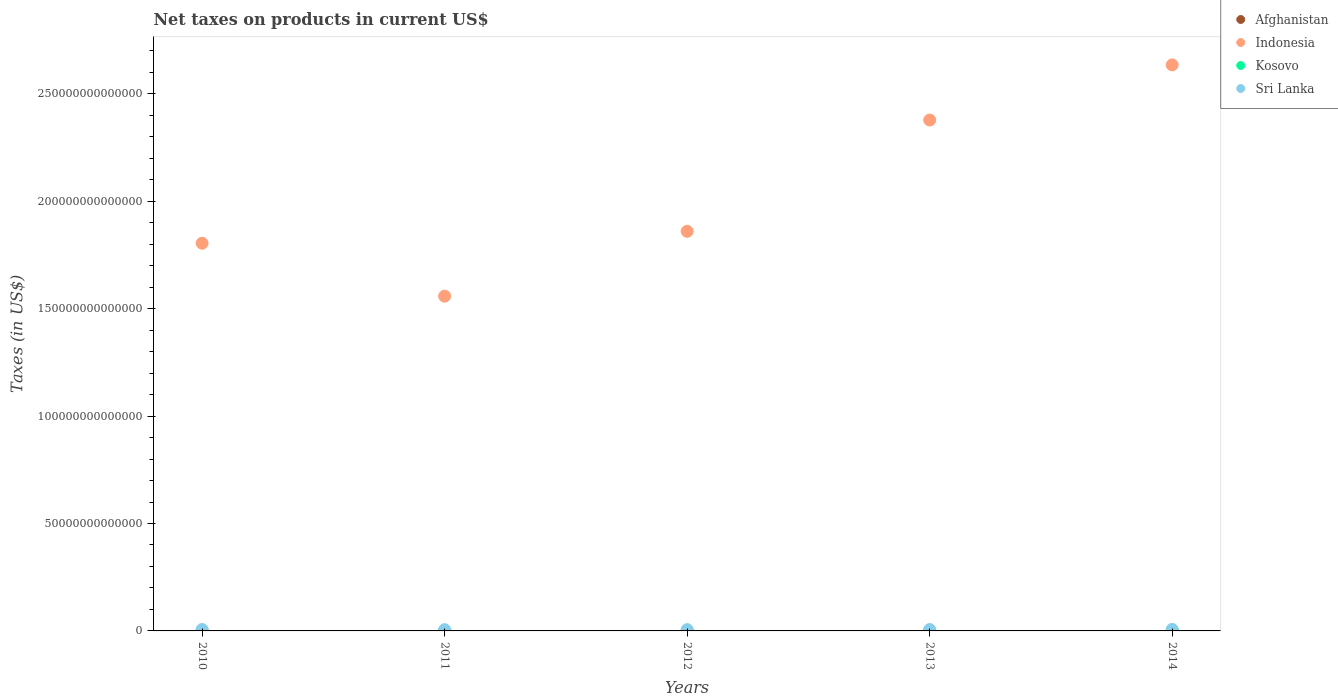How many different coloured dotlines are there?
Keep it short and to the point. 4. Is the number of dotlines equal to the number of legend labels?
Your answer should be very brief. Yes. What is the net taxes on products in Indonesia in 2011?
Provide a succinct answer. 1.56e+14. Across all years, what is the maximum net taxes on products in Kosovo?
Your answer should be very brief. 9.50e+08. Across all years, what is the minimum net taxes on products in Indonesia?
Make the answer very short. 1.56e+14. In which year was the net taxes on products in Indonesia maximum?
Your answer should be compact. 2014. What is the total net taxes on products in Indonesia in the graph?
Make the answer very short. 1.02e+15. What is the difference between the net taxes on products in Kosovo in 2011 and that in 2012?
Keep it short and to the point. -2.21e+07. What is the difference between the net taxes on products in Afghanistan in 2013 and the net taxes on products in Indonesia in 2012?
Ensure brevity in your answer.  -1.86e+14. What is the average net taxes on products in Kosovo per year?
Keep it short and to the point. 8.64e+08. In the year 2014, what is the difference between the net taxes on products in Afghanistan and net taxes on products in Sri Lanka?
Make the answer very short. -6.63e+11. What is the ratio of the net taxes on products in Kosovo in 2012 to that in 2013?
Give a very brief answer. 1. Is the difference between the net taxes on products in Afghanistan in 2011 and 2013 greater than the difference between the net taxes on products in Sri Lanka in 2011 and 2013?
Your response must be concise. Yes. What is the difference between the highest and the second highest net taxes on products in Kosovo?
Offer a very short reply. 5.82e+07. What is the difference between the highest and the lowest net taxes on products in Afghanistan?
Ensure brevity in your answer.  1.86e+1. In how many years, is the net taxes on products in Kosovo greater than the average net taxes on products in Kosovo taken over all years?
Your response must be concise. 4. Is it the case that in every year, the sum of the net taxes on products in Afghanistan and net taxes on products in Kosovo  is greater than the sum of net taxes on products in Sri Lanka and net taxes on products in Indonesia?
Make the answer very short. No. Is it the case that in every year, the sum of the net taxes on products in Sri Lanka and net taxes on products in Indonesia  is greater than the net taxes on products in Afghanistan?
Keep it short and to the point. Yes. Does the net taxes on products in Afghanistan monotonically increase over the years?
Ensure brevity in your answer.  No. Is the net taxes on products in Kosovo strictly greater than the net taxes on products in Sri Lanka over the years?
Provide a short and direct response. No. What is the difference between two consecutive major ticks on the Y-axis?
Ensure brevity in your answer.  5.00e+13. Does the graph contain any zero values?
Ensure brevity in your answer.  No. Does the graph contain grids?
Keep it short and to the point. No. How many legend labels are there?
Offer a terse response. 4. What is the title of the graph?
Your response must be concise. Net taxes on products in current US$. Does "New Zealand" appear as one of the legend labels in the graph?
Your answer should be compact. No. What is the label or title of the X-axis?
Provide a succinct answer. Years. What is the label or title of the Y-axis?
Your response must be concise. Taxes (in US$). What is the Taxes (in US$) in Afghanistan in 2010?
Give a very brief answer. 2.73e+1. What is the Taxes (in US$) of Indonesia in 2010?
Your response must be concise. 1.80e+14. What is the Taxes (in US$) of Kosovo in 2010?
Offer a very short reply. 7.15e+08. What is the Taxes (in US$) in Sri Lanka in 2010?
Your response must be concise. 6.56e+11. What is the Taxes (in US$) of Afghanistan in 2011?
Provide a short and direct response. 3.25e+1. What is the Taxes (in US$) of Indonesia in 2011?
Offer a terse response. 1.56e+14. What is the Taxes (in US$) of Kosovo in 2011?
Offer a terse response. 8.70e+08. What is the Taxes (in US$) of Sri Lanka in 2011?
Offer a very short reply. 5.80e+11. What is the Taxes (in US$) in Afghanistan in 2012?
Keep it short and to the point. 4.14e+1. What is the Taxes (in US$) in Indonesia in 2012?
Your answer should be compact. 1.86e+14. What is the Taxes (in US$) of Kosovo in 2012?
Keep it short and to the point. 8.92e+08. What is the Taxes (in US$) of Sri Lanka in 2012?
Ensure brevity in your answer.  5.93e+11. What is the Taxes (in US$) in Afghanistan in 2013?
Ensure brevity in your answer.  4.59e+1. What is the Taxes (in US$) in Indonesia in 2013?
Offer a very short reply. 2.38e+14. What is the Taxes (in US$) in Kosovo in 2013?
Your answer should be very brief. 8.91e+08. What is the Taxes (in US$) in Sri Lanka in 2013?
Provide a succinct answer. 6.53e+11. What is the Taxes (in US$) of Afghanistan in 2014?
Your answer should be compact. 4.08e+1. What is the Taxes (in US$) of Indonesia in 2014?
Offer a terse response. 2.63e+14. What is the Taxes (in US$) of Kosovo in 2014?
Make the answer very short. 9.50e+08. What is the Taxes (in US$) in Sri Lanka in 2014?
Provide a short and direct response. 7.04e+11. Across all years, what is the maximum Taxes (in US$) in Afghanistan?
Offer a terse response. 4.59e+1. Across all years, what is the maximum Taxes (in US$) in Indonesia?
Give a very brief answer. 2.63e+14. Across all years, what is the maximum Taxes (in US$) in Kosovo?
Make the answer very short. 9.50e+08. Across all years, what is the maximum Taxes (in US$) of Sri Lanka?
Your answer should be compact. 7.04e+11. Across all years, what is the minimum Taxes (in US$) in Afghanistan?
Ensure brevity in your answer.  2.73e+1. Across all years, what is the minimum Taxes (in US$) in Indonesia?
Provide a succinct answer. 1.56e+14. Across all years, what is the minimum Taxes (in US$) of Kosovo?
Make the answer very short. 7.15e+08. Across all years, what is the minimum Taxes (in US$) of Sri Lanka?
Ensure brevity in your answer.  5.80e+11. What is the total Taxes (in US$) of Afghanistan in the graph?
Your response must be concise. 1.88e+11. What is the total Taxes (in US$) of Indonesia in the graph?
Offer a terse response. 1.02e+15. What is the total Taxes (in US$) in Kosovo in the graph?
Your answer should be compact. 4.32e+09. What is the total Taxes (in US$) of Sri Lanka in the graph?
Keep it short and to the point. 3.19e+12. What is the difference between the Taxes (in US$) in Afghanistan in 2010 and that in 2011?
Ensure brevity in your answer.  -5.18e+09. What is the difference between the Taxes (in US$) of Indonesia in 2010 and that in 2011?
Provide a short and direct response. 2.46e+13. What is the difference between the Taxes (in US$) in Kosovo in 2010 and that in 2011?
Your answer should be compact. -1.55e+08. What is the difference between the Taxes (in US$) in Sri Lanka in 2010 and that in 2011?
Give a very brief answer. 7.56e+1. What is the difference between the Taxes (in US$) of Afghanistan in 2010 and that in 2012?
Provide a succinct answer. -1.41e+1. What is the difference between the Taxes (in US$) of Indonesia in 2010 and that in 2012?
Provide a succinct answer. -5.55e+12. What is the difference between the Taxes (in US$) of Kosovo in 2010 and that in 2012?
Your answer should be very brief. -1.77e+08. What is the difference between the Taxes (in US$) in Sri Lanka in 2010 and that in 2012?
Ensure brevity in your answer.  6.27e+1. What is the difference between the Taxes (in US$) in Afghanistan in 2010 and that in 2013?
Your answer should be compact. -1.86e+1. What is the difference between the Taxes (in US$) in Indonesia in 2010 and that in 2013?
Make the answer very short. -5.73e+13. What is the difference between the Taxes (in US$) in Kosovo in 2010 and that in 2013?
Ensure brevity in your answer.  -1.76e+08. What is the difference between the Taxes (in US$) of Sri Lanka in 2010 and that in 2013?
Your answer should be very brief. 2.69e+09. What is the difference between the Taxes (in US$) of Afghanistan in 2010 and that in 2014?
Keep it short and to the point. -1.35e+1. What is the difference between the Taxes (in US$) in Indonesia in 2010 and that in 2014?
Give a very brief answer. -8.30e+13. What is the difference between the Taxes (in US$) of Kosovo in 2010 and that in 2014?
Offer a terse response. -2.35e+08. What is the difference between the Taxes (in US$) in Sri Lanka in 2010 and that in 2014?
Provide a succinct answer. -4.84e+1. What is the difference between the Taxes (in US$) of Afghanistan in 2011 and that in 2012?
Give a very brief answer. -8.92e+09. What is the difference between the Taxes (in US$) of Indonesia in 2011 and that in 2012?
Make the answer very short. -3.02e+13. What is the difference between the Taxes (in US$) in Kosovo in 2011 and that in 2012?
Offer a terse response. -2.21e+07. What is the difference between the Taxes (in US$) in Sri Lanka in 2011 and that in 2012?
Your answer should be compact. -1.29e+1. What is the difference between the Taxes (in US$) in Afghanistan in 2011 and that in 2013?
Your response must be concise. -1.34e+1. What is the difference between the Taxes (in US$) of Indonesia in 2011 and that in 2013?
Provide a succinct answer. -8.20e+13. What is the difference between the Taxes (in US$) of Kosovo in 2011 and that in 2013?
Ensure brevity in your answer.  -2.14e+07. What is the difference between the Taxes (in US$) of Sri Lanka in 2011 and that in 2013?
Provide a succinct answer. -7.29e+1. What is the difference between the Taxes (in US$) in Afghanistan in 2011 and that in 2014?
Your response must be concise. -8.36e+09. What is the difference between the Taxes (in US$) of Indonesia in 2011 and that in 2014?
Offer a very short reply. -1.08e+14. What is the difference between the Taxes (in US$) of Kosovo in 2011 and that in 2014?
Offer a very short reply. -8.03e+07. What is the difference between the Taxes (in US$) of Sri Lanka in 2011 and that in 2014?
Ensure brevity in your answer.  -1.24e+11. What is the difference between the Taxes (in US$) in Afghanistan in 2012 and that in 2013?
Offer a very short reply. -4.46e+09. What is the difference between the Taxes (in US$) of Indonesia in 2012 and that in 2013?
Make the answer very short. -5.18e+13. What is the difference between the Taxes (in US$) in Kosovo in 2012 and that in 2013?
Your answer should be very brief. 7.00e+05. What is the difference between the Taxes (in US$) of Sri Lanka in 2012 and that in 2013?
Your answer should be compact. -6.00e+1. What is the difference between the Taxes (in US$) of Afghanistan in 2012 and that in 2014?
Offer a very short reply. 5.57e+08. What is the difference between the Taxes (in US$) of Indonesia in 2012 and that in 2014?
Your response must be concise. -7.75e+13. What is the difference between the Taxes (in US$) of Kosovo in 2012 and that in 2014?
Provide a short and direct response. -5.82e+07. What is the difference between the Taxes (in US$) in Sri Lanka in 2012 and that in 2014?
Offer a terse response. -1.11e+11. What is the difference between the Taxes (in US$) of Afghanistan in 2013 and that in 2014?
Your answer should be very brief. 5.02e+09. What is the difference between the Taxes (in US$) in Indonesia in 2013 and that in 2014?
Offer a very short reply. -2.57e+13. What is the difference between the Taxes (in US$) of Kosovo in 2013 and that in 2014?
Your response must be concise. -5.89e+07. What is the difference between the Taxes (in US$) of Sri Lanka in 2013 and that in 2014?
Ensure brevity in your answer.  -5.11e+1. What is the difference between the Taxes (in US$) in Afghanistan in 2010 and the Taxes (in US$) in Indonesia in 2011?
Provide a short and direct response. -1.56e+14. What is the difference between the Taxes (in US$) of Afghanistan in 2010 and the Taxes (in US$) of Kosovo in 2011?
Offer a terse response. 2.64e+1. What is the difference between the Taxes (in US$) in Afghanistan in 2010 and the Taxes (in US$) in Sri Lanka in 2011?
Make the answer very short. -5.53e+11. What is the difference between the Taxes (in US$) of Indonesia in 2010 and the Taxes (in US$) of Kosovo in 2011?
Keep it short and to the point. 1.80e+14. What is the difference between the Taxes (in US$) of Indonesia in 2010 and the Taxes (in US$) of Sri Lanka in 2011?
Ensure brevity in your answer.  1.80e+14. What is the difference between the Taxes (in US$) in Kosovo in 2010 and the Taxes (in US$) in Sri Lanka in 2011?
Your answer should be compact. -5.79e+11. What is the difference between the Taxes (in US$) of Afghanistan in 2010 and the Taxes (in US$) of Indonesia in 2012?
Make the answer very short. -1.86e+14. What is the difference between the Taxes (in US$) of Afghanistan in 2010 and the Taxes (in US$) of Kosovo in 2012?
Your response must be concise. 2.64e+1. What is the difference between the Taxes (in US$) in Afghanistan in 2010 and the Taxes (in US$) in Sri Lanka in 2012?
Keep it short and to the point. -5.66e+11. What is the difference between the Taxes (in US$) of Indonesia in 2010 and the Taxes (in US$) of Kosovo in 2012?
Provide a succinct answer. 1.80e+14. What is the difference between the Taxes (in US$) of Indonesia in 2010 and the Taxes (in US$) of Sri Lanka in 2012?
Offer a terse response. 1.80e+14. What is the difference between the Taxes (in US$) of Kosovo in 2010 and the Taxes (in US$) of Sri Lanka in 2012?
Your answer should be compact. -5.92e+11. What is the difference between the Taxes (in US$) of Afghanistan in 2010 and the Taxes (in US$) of Indonesia in 2013?
Make the answer very short. -2.38e+14. What is the difference between the Taxes (in US$) in Afghanistan in 2010 and the Taxes (in US$) in Kosovo in 2013?
Provide a short and direct response. 2.64e+1. What is the difference between the Taxes (in US$) of Afghanistan in 2010 and the Taxes (in US$) of Sri Lanka in 2013?
Your answer should be compact. -6.26e+11. What is the difference between the Taxes (in US$) of Indonesia in 2010 and the Taxes (in US$) of Kosovo in 2013?
Give a very brief answer. 1.80e+14. What is the difference between the Taxes (in US$) in Indonesia in 2010 and the Taxes (in US$) in Sri Lanka in 2013?
Keep it short and to the point. 1.80e+14. What is the difference between the Taxes (in US$) of Kosovo in 2010 and the Taxes (in US$) of Sri Lanka in 2013?
Keep it short and to the point. -6.52e+11. What is the difference between the Taxes (in US$) of Afghanistan in 2010 and the Taxes (in US$) of Indonesia in 2014?
Your answer should be very brief. -2.63e+14. What is the difference between the Taxes (in US$) in Afghanistan in 2010 and the Taxes (in US$) in Kosovo in 2014?
Keep it short and to the point. 2.63e+1. What is the difference between the Taxes (in US$) in Afghanistan in 2010 and the Taxes (in US$) in Sri Lanka in 2014?
Offer a terse response. -6.77e+11. What is the difference between the Taxes (in US$) of Indonesia in 2010 and the Taxes (in US$) of Kosovo in 2014?
Provide a succinct answer. 1.80e+14. What is the difference between the Taxes (in US$) of Indonesia in 2010 and the Taxes (in US$) of Sri Lanka in 2014?
Your answer should be compact. 1.80e+14. What is the difference between the Taxes (in US$) in Kosovo in 2010 and the Taxes (in US$) in Sri Lanka in 2014?
Offer a terse response. -7.03e+11. What is the difference between the Taxes (in US$) in Afghanistan in 2011 and the Taxes (in US$) in Indonesia in 2012?
Make the answer very short. -1.86e+14. What is the difference between the Taxes (in US$) of Afghanistan in 2011 and the Taxes (in US$) of Kosovo in 2012?
Offer a very short reply. 3.16e+1. What is the difference between the Taxes (in US$) in Afghanistan in 2011 and the Taxes (in US$) in Sri Lanka in 2012?
Make the answer very short. -5.60e+11. What is the difference between the Taxes (in US$) in Indonesia in 2011 and the Taxes (in US$) in Kosovo in 2012?
Your response must be concise. 1.56e+14. What is the difference between the Taxes (in US$) of Indonesia in 2011 and the Taxes (in US$) of Sri Lanka in 2012?
Offer a terse response. 1.55e+14. What is the difference between the Taxes (in US$) in Kosovo in 2011 and the Taxes (in US$) in Sri Lanka in 2012?
Keep it short and to the point. -5.92e+11. What is the difference between the Taxes (in US$) of Afghanistan in 2011 and the Taxes (in US$) of Indonesia in 2013?
Provide a short and direct response. -2.38e+14. What is the difference between the Taxes (in US$) in Afghanistan in 2011 and the Taxes (in US$) in Kosovo in 2013?
Your answer should be very brief. 3.16e+1. What is the difference between the Taxes (in US$) of Afghanistan in 2011 and the Taxes (in US$) of Sri Lanka in 2013?
Ensure brevity in your answer.  -6.20e+11. What is the difference between the Taxes (in US$) in Indonesia in 2011 and the Taxes (in US$) in Kosovo in 2013?
Provide a short and direct response. 1.56e+14. What is the difference between the Taxes (in US$) in Indonesia in 2011 and the Taxes (in US$) in Sri Lanka in 2013?
Provide a succinct answer. 1.55e+14. What is the difference between the Taxes (in US$) of Kosovo in 2011 and the Taxes (in US$) of Sri Lanka in 2013?
Offer a very short reply. -6.52e+11. What is the difference between the Taxes (in US$) in Afghanistan in 2011 and the Taxes (in US$) in Indonesia in 2014?
Make the answer very short. -2.63e+14. What is the difference between the Taxes (in US$) in Afghanistan in 2011 and the Taxes (in US$) in Kosovo in 2014?
Make the answer very short. 3.15e+1. What is the difference between the Taxes (in US$) in Afghanistan in 2011 and the Taxes (in US$) in Sri Lanka in 2014?
Offer a very short reply. -6.71e+11. What is the difference between the Taxes (in US$) in Indonesia in 2011 and the Taxes (in US$) in Kosovo in 2014?
Your answer should be very brief. 1.56e+14. What is the difference between the Taxes (in US$) in Indonesia in 2011 and the Taxes (in US$) in Sri Lanka in 2014?
Make the answer very short. 1.55e+14. What is the difference between the Taxes (in US$) in Kosovo in 2011 and the Taxes (in US$) in Sri Lanka in 2014?
Provide a short and direct response. -7.03e+11. What is the difference between the Taxes (in US$) in Afghanistan in 2012 and the Taxes (in US$) in Indonesia in 2013?
Ensure brevity in your answer.  -2.38e+14. What is the difference between the Taxes (in US$) of Afghanistan in 2012 and the Taxes (in US$) of Kosovo in 2013?
Keep it short and to the point. 4.05e+1. What is the difference between the Taxes (in US$) in Afghanistan in 2012 and the Taxes (in US$) in Sri Lanka in 2013?
Keep it short and to the point. -6.11e+11. What is the difference between the Taxes (in US$) of Indonesia in 2012 and the Taxes (in US$) of Kosovo in 2013?
Give a very brief answer. 1.86e+14. What is the difference between the Taxes (in US$) in Indonesia in 2012 and the Taxes (in US$) in Sri Lanka in 2013?
Offer a very short reply. 1.85e+14. What is the difference between the Taxes (in US$) in Kosovo in 2012 and the Taxes (in US$) in Sri Lanka in 2013?
Provide a short and direct response. -6.52e+11. What is the difference between the Taxes (in US$) in Afghanistan in 2012 and the Taxes (in US$) in Indonesia in 2014?
Keep it short and to the point. -2.63e+14. What is the difference between the Taxes (in US$) in Afghanistan in 2012 and the Taxes (in US$) in Kosovo in 2014?
Offer a very short reply. 4.04e+1. What is the difference between the Taxes (in US$) in Afghanistan in 2012 and the Taxes (in US$) in Sri Lanka in 2014?
Your answer should be very brief. -6.63e+11. What is the difference between the Taxes (in US$) in Indonesia in 2012 and the Taxes (in US$) in Kosovo in 2014?
Your response must be concise. 1.86e+14. What is the difference between the Taxes (in US$) of Indonesia in 2012 and the Taxes (in US$) of Sri Lanka in 2014?
Give a very brief answer. 1.85e+14. What is the difference between the Taxes (in US$) in Kosovo in 2012 and the Taxes (in US$) in Sri Lanka in 2014?
Make the answer very short. -7.03e+11. What is the difference between the Taxes (in US$) of Afghanistan in 2013 and the Taxes (in US$) of Indonesia in 2014?
Ensure brevity in your answer.  -2.63e+14. What is the difference between the Taxes (in US$) of Afghanistan in 2013 and the Taxes (in US$) of Kosovo in 2014?
Make the answer very short. 4.49e+1. What is the difference between the Taxes (in US$) in Afghanistan in 2013 and the Taxes (in US$) in Sri Lanka in 2014?
Provide a short and direct response. -6.58e+11. What is the difference between the Taxes (in US$) of Indonesia in 2013 and the Taxes (in US$) of Kosovo in 2014?
Your answer should be very brief. 2.38e+14. What is the difference between the Taxes (in US$) of Indonesia in 2013 and the Taxes (in US$) of Sri Lanka in 2014?
Give a very brief answer. 2.37e+14. What is the difference between the Taxes (in US$) in Kosovo in 2013 and the Taxes (in US$) in Sri Lanka in 2014?
Provide a succinct answer. -7.03e+11. What is the average Taxes (in US$) in Afghanistan per year?
Provide a short and direct response. 3.76e+1. What is the average Taxes (in US$) of Indonesia per year?
Offer a terse response. 2.05e+14. What is the average Taxes (in US$) of Kosovo per year?
Give a very brief answer. 8.64e+08. What is the average Taxes (in US$) in Sri Lanka per year?
Your answer should be compact. 6.37e+11. In the year 2010, what is the difference between the Taxes (in US$) in Afghanistan and Taxes (in US$) in Indonesia?
Your answer should be compact. -1.80e+14. In the year 2010, what is the difference between the Taxes (in US$) in Afghanistan and Taxes (in US$) in Kosovo?
Make the answer very short. 2.66e+1. In the year 2010, what is the difference between the Taxes (in US$) of Afghanistan and Taxes (in US$) of Sri Lanka?
Offer a terse response. -6.28e+11. In the year 2010, what is the difference between the Taxes (in US$) in Indonesia and Taxes (in US$) in Kosovo?
Make the answer very short. 1.80e+14. In the year 2010, what is the difference between the Taxes (in US$) of Indonesia and Taxes (in US$) of Sri Lanka?
Provide a succinct answer. 1.80e+14. In the year 2010, what is the difference between the Taxes (in US$) in Kosovo and Taxes (in US$) in Sri Lanka?
Your response must be concise. -6.55e+11. In the year 2011, what is the difference between the Taxes (in US$) in Afghanistan and Taxes (in US$) in Indonesia?
Offer a very short reply. -1.56e+14. In the year 2011, what is the difference between the Taxes (in US$) of Afghanistan and Taxes (in US$) of Kosovo?
Make the answer very short. 3.16e+1. In the year 2011, what is the difference between the Taxes (in US$) of Afghanistan and Taxes (in US$) of Sri Lanka?
Your answer should be compact. -5.48e+11. In the year 2011, what is the difference between the Taxes (in US$) in Indonesia and Taxes (in US$) in Kosovo?
Your answer should be very brief. 1.56e+14. In the year 2011, what is the difference between the Taxes (in US$) in Indonesia and Taxes (in US$) in Sri Lanka?
Ensure brevity in your answer.  1.55e+14. In the year 2011, what is the difference between the Taxes (in US$) in Kosovo and Taxes (in US$) in Sri Lanka?
Offer a terse response. -5.79e+11. In the year 2012, what is the difference between the Taxes (in US$) in Afghanistan and Taxes (in US$) in Indonesia?
Offer a very short reply. -1.86e+14. In the year 2012, what is the difference between the Taxes (in US$) in Afghanistan and Taxes (in US$) in Kosovo?
Offer a very short reply. 4.05e+1. In the year 2012, what is the difference between the Taxes (in US$) in Afghanistan and Taxes (in US$) in Sri Lanka?
Give a very brief answer. -5.52e+11. In the year 2012, what is the difference between the Taxes (in US$) of Indonesia and Taxes (in US$) of Kosovo?
Make the answer very short. 1.86e+14. In the year 2012, what is the difference between the Taxes (in US$) in Indonesia and Taxes (in US$) in Sri Lanka?
Your answer should be very brief. 1.85e+14. In the year 2012, what is the difference between the Taxes (in US$) in Kosovo and Taxes (in US$) in Sri Lanka?
Provide a short and direct response. -5.92e+11. In the year 2013, what is the difference between the Taxes (in US$) of Afghanistan and Taxes (in US$) of Indonesia?
Your response must be concise. -2.38e+14. In the year 2013, what is the difference between the Taxes (in US$) in Afghanistan and Taxes (in US$) in Kosovo?
Your answer should be very brief. 4.50e+1. In the year 2013, what is the difference between the Taxes (in US$) in Afghanistan and Taxes (in US$) in Sri Lanka?
Give a very brief answer. -6.07e+11. In the year 2013, what is the difference between the Taxes (in US$) in Indonesia and Taxes (in US$) in Kosovo?
Give a very brief answer. 2.38e+14. In the year 2013, what is the difference between the Taxes (in US$) in Indonesia and Taxes (in US$) in Sri Lanka?
Give a very brief answer. 2.37e+14. In the year 2013, what is the difference between the Taxes (in US$) in Kosovo and Taxes (in US$) in Sri Lanka?
Provide a succinct answer. -6.52e+11. In the year 2014, what is the difference between the Taxes (in US$) in Afghanistan and Taxes (in US$) in Indonesia?
Provide a succinct answer. -2.63e+14. In the year 2014, what is the difference between the Taxes (in US$) of Afghanistan and Taxes (in US$) of Kosovo?
Provide a short and direct response. 3.99e+1. In the year 2014, what is the difference between the Taxes (in US$) of Afghanistan and Taxes (in US$) of Sri Lanka?
Your answer should be very brief. -6.63e+11. In the year 2014, what is the difference between the Taxes (in US$) in Indonesia and Taxes (in US$) in Kosovo?
Your answer should be compact. 2.63e+14. In the year 2014, what is the difference between the Taxes (in US$) in Indonesia and Taxes (in US$) in Sri Lanka?
Your answer should be compact. 2.63e+14. In the year 2014, what is the difference between the Taxes (in US$) of Kosovo and Taxes (in US$) of Sri Lanka?
Make the answer very short. -7.03e+11. What is the ratio of the Taxes (in US$) of Afghanistan in 2010 to that in 2011?
Offer a very short reply. 0.84. What is the ratio of the Taxes (in US$) of Indonesia in 2010 to that in 2011?
Your response must be concise. 1.16. What is the ratio of the Taxes (in US$) in Kosovo in 2010 to that in 2011?
Offer a terse response. 0.82. What is the ratio of the Taxes (in US$) in Sri Lanka in 2010 to that in 2011?
Your response must be concise. 1.13. What is the ratio of the Taxes (in US$) of Afghanistan in 2010 to that in 2012?
Your answer should be compact. 0.66. What is the ratio of the Taxes (in US$) of Indonesia in 2010 to that in 2012?
Your response must be concise. 0.97. What is the ratio of the Taxes (in US$) in Kosovo in 2010 to that in 2012?
Provide a short and direct response. 0.8. What is the ratio of the Taxes (in US$) in Sri Lanka in 2010 to that in 2012?
Ensure brevity in your answer.  1.11. What is the ratio of the Taxes (in US$) in Afghanistan in 2010 to that in 2013?
Offer a very short reply. 0.6. What is the ratio of the Taxes (in US$) in Indonesia in 2010 to that in 2013?
Offer a terse response. 0.76. What is the ratio of the Taxes (in US$) in Kosovo in 2010 to that in 2013?
Your answer should be compact. 0.8. What is the ratio of the Taxes (in US$) in Afghanistan in 2010 to that in 2014?
Give a very brief answer. 0.67. What is the ratio of the Taxes (in US$) in Indonesia in 2010 to that in 2014?
Your response must be concise. 0.68. What is the ratio of the Taxes (in US$) of Kosovo in 2010 to that in 2014?
Make the answer very short. 0.75. What is the ratio of the Taxes (in US$) of Sri Lanka in 2010 to that in 2014?
Offer a very short reply. 0.93. What is the ratio of the Taxes (in US$) of Afghanistan in 2011 to that in 2012?
Provide a short and direct response. 0.78. What is the ratio of the Taxes (in US$) in Indonesia in 2011 to that in 2012?
Provide a short and direct response. 0.84. What is the ratio of the Taxes (in US$) in Kosovo in 2011 to that in 2012?
Provide a succinct answer. 0.98. What is the ratio of the Taxes (in US$) of Sri Lanka in 2011 to that in 2012?
Offer a terse response. 0.98. What is the ratio of the Taxes (in US$) of Afghanistan in 2011 to that in 2013?
Provide a succinct answer. 0.71. What is the ratio of the Taxes (in US$) of Indonesia in 2011 to that in 2013?
Provide a short and direct response. 0.66. What is the ratio of the Taxes (in US$) of Sri Lanka in 2011 to that in 2013?
Give a very brief answer. 0.89. What is the ratio of the Taxes (in US$) in Afghanistan in 2011 to that in 2014?
Offer a terse response. 0.8. What is the ratio of the Taxes (in US$) of Indonesia in 2011 to that in 2014?
Make the answer very short. 0.59. What is the ratio of the Taxes (in US$) in Kosovo in 2011 to that in 2014?
Provide a short and direct response. 0.92. What is the ratio of the Taxes (in US$) of Sri Lanka in 2011 to that in 2014?
Make the answer very short. 0.82. What is the ratio of the Taxes (in US$) in Afghanistan in 2012 to that in 2013?
Make the answer very short. 0.9. What is the ratio of the Taxes (in US$) of Indonesia in 2012 to that in 2013?
Offer a very short reply. 0.78. What is the ratio of the Taxes (in US$) in Sri Lanka in 2012 to that in 2013?
Your response must be concise. 0.91. What is the ratio of the Taxes (in US$) in Afghanistan in 2012 to that in 2014?
Your answer should be compact. 1.01. What is the ratio of the Taxes (in US$) in Indonesia in 2012 to that in 2014?
Make the answer very short. 0.71. What is the ratio of the Taxes (in US$) of Kosovo in 2012 to that in 2014?
Ensure brevity in your answer.  0.94. What is the ratio of the Taxes (in US$) of Sri Lanka in 2012 to that in 2014?
Your answer should be very brief. 0.84. What is the ratio of the Taxes (in US$) in Afghanistan in 2013 to that in 2014?
Make the answer very short. 1.12. What is the ratio of the Taxes (in US$) of Indonesia in 2013 to that in 2014?
Make the answer very short. 0.9. What is the ratio of the Taxes (in US$) of Kosovo in 2013 to that in 2014?
Your answer should be compact. 0.94. What is the ratio of the Taxes (in US$) in Sri Lanka in 2013 to that in 2014?
Ensure brevity in your answer.  0.93. What is the difference between the highest and the second highest Taxes (in US$) of Afghanistan?
Keep it short and to the point. 4.46e+09. What is the difference between the highest and the second highest Taxes (in US$) in Indonesia?
Give a very brief answer. 2.57e+13. What is the difference between the highest and the second highest Taxes (in US$) of Kosovo?
Offer a very short reply. 5.82e+07. What is the difference between the highest and the second highest Taxes (in US$) in Sri Lanka?
Ensure brevity in your answer.  4.84e+1. What is the difference between the highest and the lowest Taxes (in US$) of Afghanistan?
Provide a succinct answer. 1.86e+1. What is the difference between the highest and the lowest Taxes (in US$) in Indonesia?
Offer a very short reply. 1.08e+14. What is the difference between the highest and the lowest Taxes (in US$) in Kosovo?
Give a very brief answer. 2.35e+08. What is the difference between the highest and the lowest Taxes (in US$) in Sri Lanka?
Your answer should be very brief. 1.24e+11. 